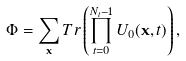<formula> <loc_0><loc_0><loc_500><loc_500>\Phi = \sum _ { \mathbf x } T r \left ( \prod _ { t = 0 } ^ { N _ { t } - 1 } U _ { 0 } ( { \mathbf x } , t ) \right ) ,</formula> 